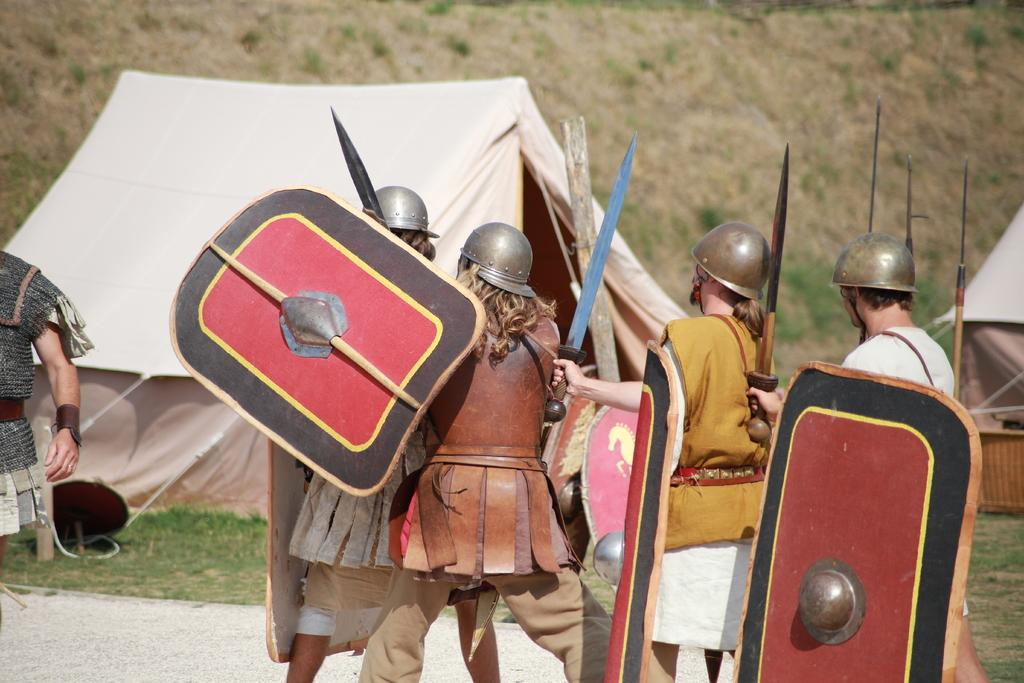What are the people in the image doing? The people in the image are walking on the ground. What objects are the people holding? The people are holding boards and a sword. What type of terrain is visible in the image? There is grass visible in the image. What structures can be seen on the grass? There are tents on the grass in the image. What type of news can be heard coming from the tents in the image? There is no indication in the image that there is any news being broadcast or discussed. 